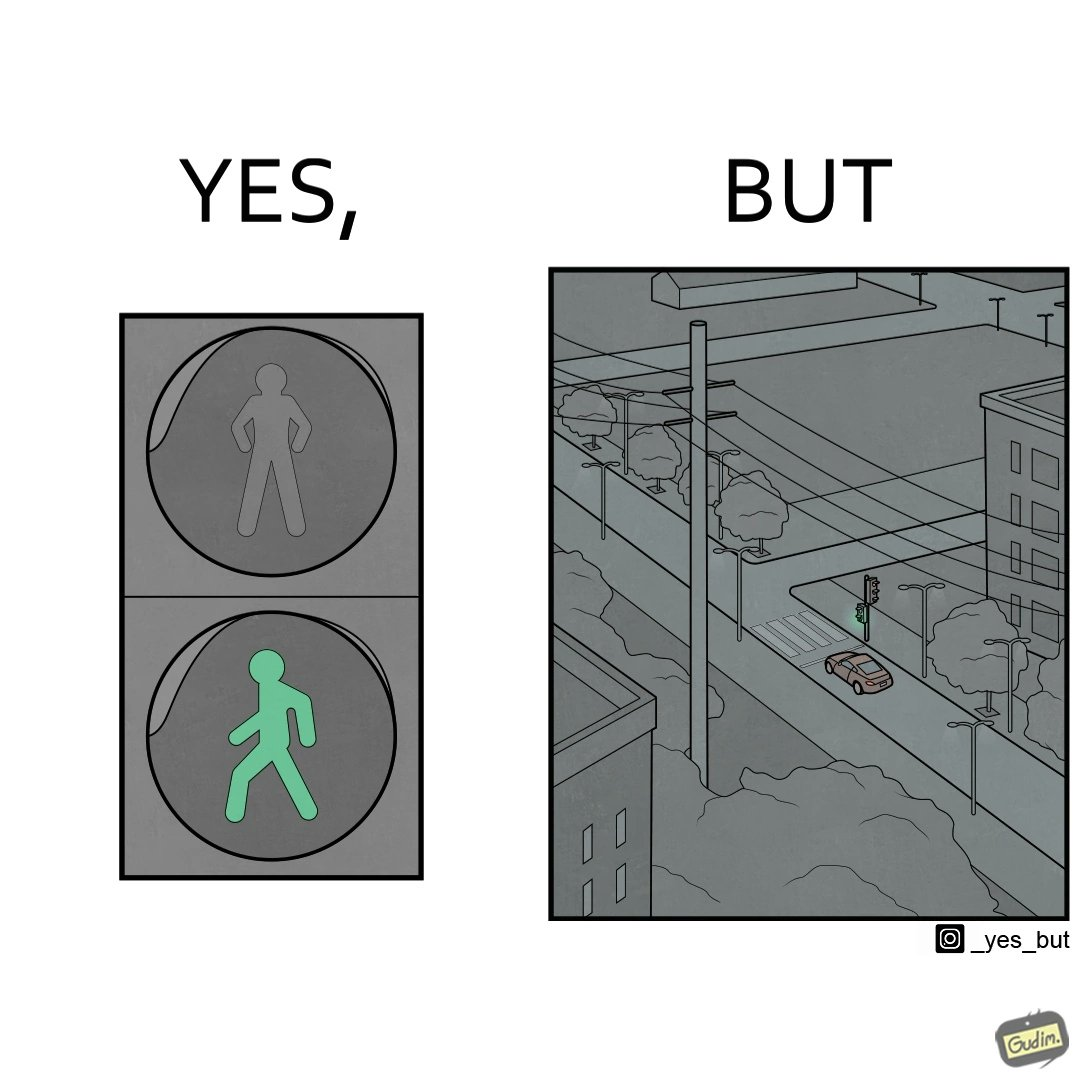What does this image depict? The image is funny because while walk signs are very useful for pedestrians to be able to cross roads safely, the become unnecessary and annoying for car drivers when these signals turn green even when there is no pedestrian tring to cross the road. 